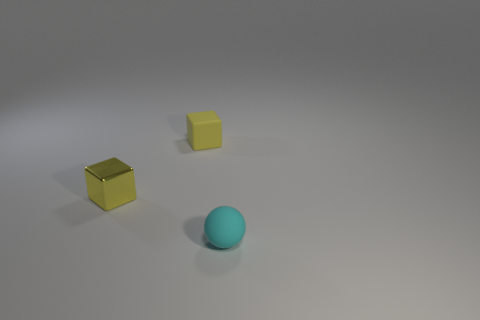What number of objects are red spheres or small yellow matte things?
Ensure brevity in your answer.  1. There is a cyan rubber object that is the same size as the yellow matte block; what is its shape?
Offer a terse response. Sphere. How many small objects are to the left of the yellow matte thing and to the right of the tiny rubber cube?
Provide a succinct answer. 0. What material is the small yellow block to the right of the yellow shiny block?
Your answer should be very brief. Rubber. What is the size of the yellow cube that is made of the same material as the small cyan ball?
Provide a succinct answer. Small. Does the matte thing that is left of the small cyan thing have the same size as the rubber thing in front of the tiny metallic block?
Keep it short and to the point. Yes. What is the material of the other cube that is the same size as the matte cube?
Your response must be concise. Metal. What material is the thing that is behind the small cyan matte ball and in front of the small rubber block?
Provide a succinct answer. Metal. Are any small shiny cubes visible?
Make the answer very short. Yes. Does the small sphere have the same color as the rubber thing that is behind the cyan rubber sphere?
Offer a very short reply. No. 